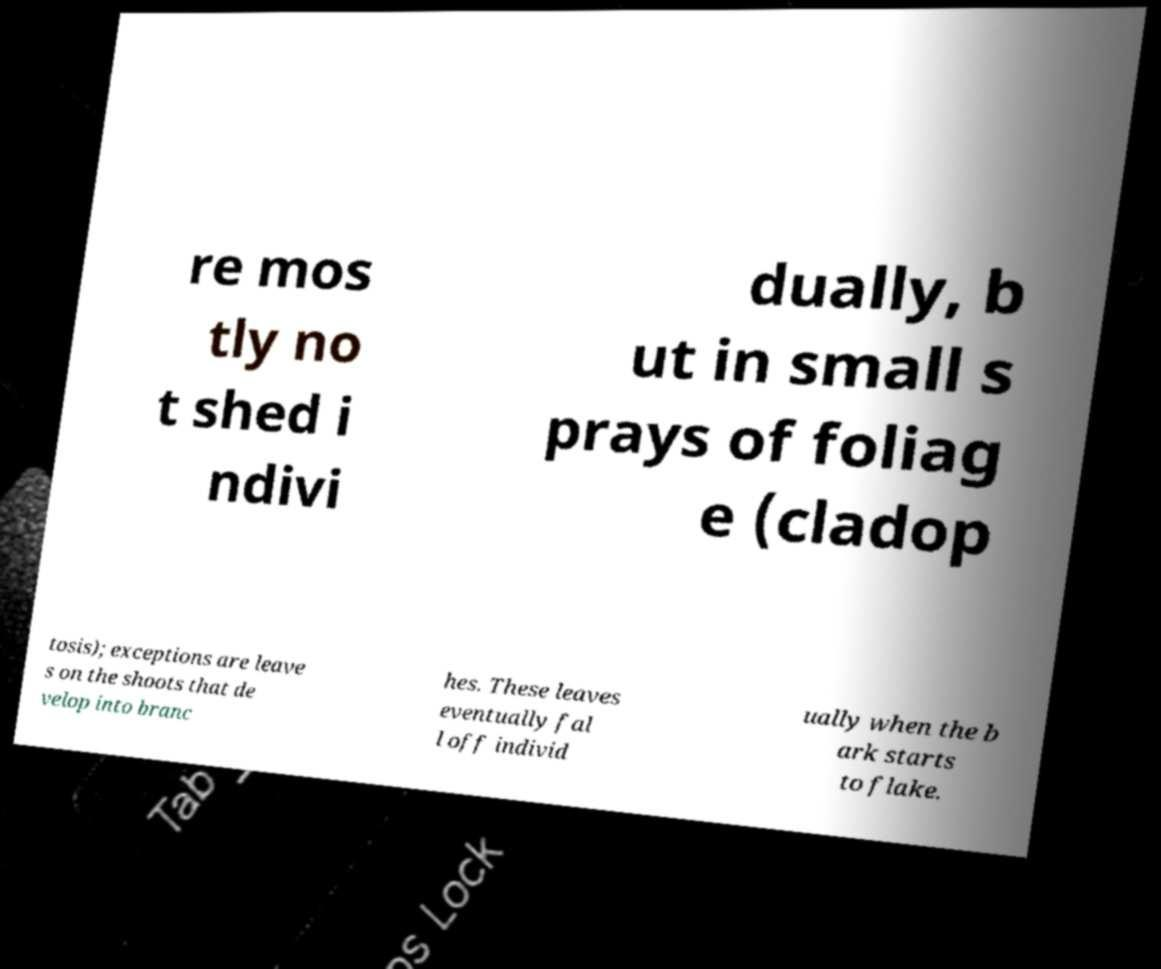Can you read and provide the text displayed in the image?This photo seems to have some interesting text. Can you extract and type it out for me? re mos tly no t shed i ndivi dually, b ut in small s prays of foliag e (cladop tosis); exceptions are leave s on the shoots that de velop into branc hes. These leaves eventually fal l off individ ually when the b ark starts to flake. 